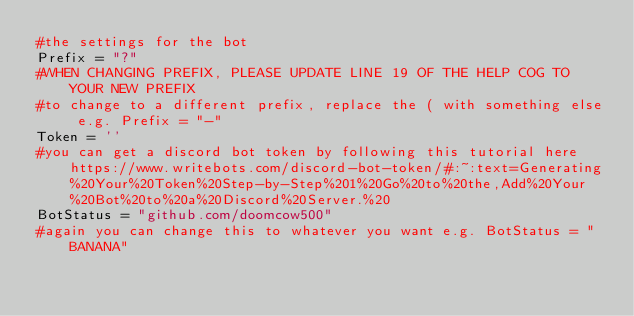<code> <loc_0><loc_0><loc_500><loc_500><_Python_>#the settings for the bot
Prefix = "?" 
#WHEN CHANGING PREFIX, PLEASE UPDATE LINE 19 OF THE HELP COG TO YOUR NEW PREFIX
#to change to a different prefix, replace the ( with something else e.g. Prefix = "-"
Token = '' 
#you can get a discord bot token by following this tutorial here https://www.writebots.com/discord-bot-token/#:~:text=Generating%20Your%20Token%20Step-by-Step%201%20Go%20to%20the,Add%20Your%20Bot%20to%20a%20Discord%20Server.%20
BotStatus = "github.com/doomcow500" 
#again you can change this to whatever you want e.g. BotStatus = "BANANA"</code> 